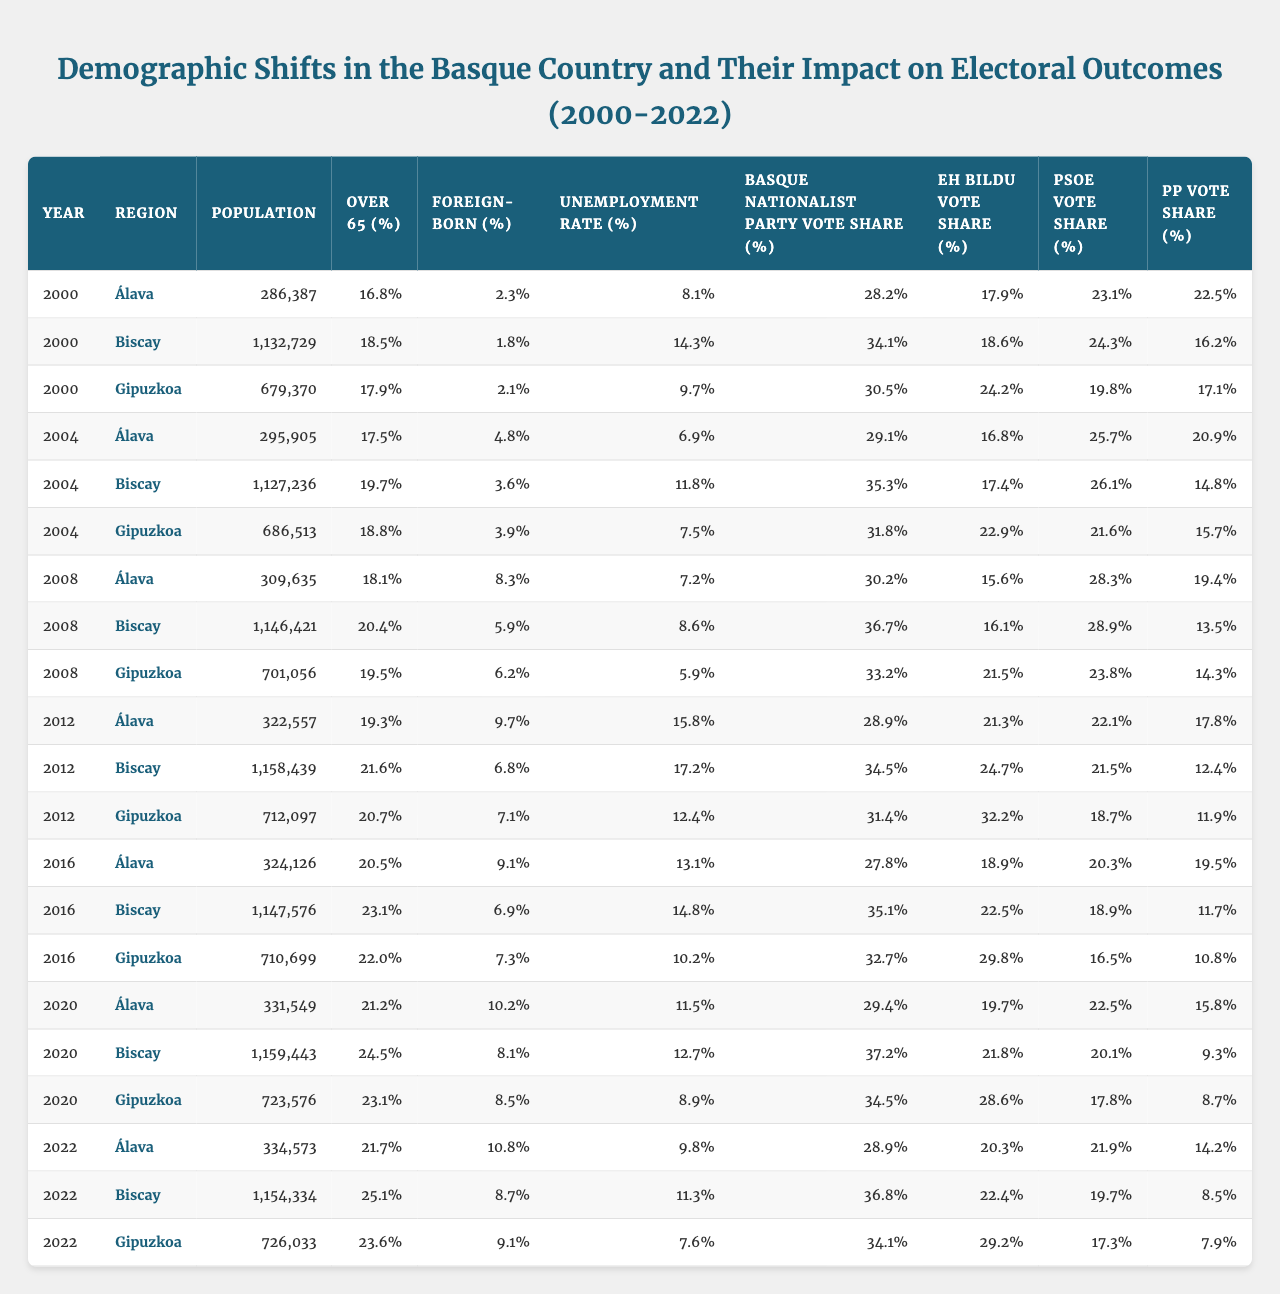What was the unemployment rate in Biscay in 2012? From the table, I look for the row where the year is 2012 and the region is Biscay. The unemployment rate for Biscay in that year is listed as 17.2%.
Answer: 17.2% Which region had the highest foreign-born percentage in 2020? Checking the rows for the year 2020, I compare the foreign-born percentages for Álava (10.2%), Biscay (8.1%), and Gipuzkoa (8.5%). Álava has the highest percentage at 10.2%.
Answer: Álava What is the average percentage of people over 65 in Gipuzkoa across all years? I sum the over 65 percentages for Gipuzkoa from each year: (17.9 + 18.8 + 19.5 + 20.7 + 22.0 + 23.1 + 23.6) = 145.6. There are 7 data points, so the average is 145.6 / 7 ≈ 20.8%.
Answer: 20.8% Did the Basque Nationalist Party’s vote share increase from 2000 to 2022 in Biscay? I compare the Basque Nationalist Party’s vote shares in Biscay for 2000 (34.1%) and 2022 (36.8%). Since 36.8% is greater than 34.1%, it means the party's vote share has increased.
Answer: Yes What was the percentage difference in PSOE vote share between Gipuzkoa in 2020 and 2022? First, I find the PSOE vote shares for Gipuzkoa: in 2020 it is 17.8% and in 2022 it is 17.3%. The difference is 17.8 - 17.3 = 0.5%, indicating a decrease.
Answer: 0.5% Which region had the lowest voter share for the PP in 2020? Checking the table for 2020, I find the PP vote shares: Álava (15.8%), Biscay (9.3%), and Gipuzkoa (8.7%). Gipuzkoa has the lowest vote share at 8.7%.
Answer: Gipuzkoa How did the unemployment rate in Álava change from 2004 to 2022? In 2004, the unemployment rate in Álava is 6.9%. By 2022, it has changed to 9.8%. The increase is calculated as 9.8 - 6.9 = 2.9 percentage points.
Answer: Increased by 2.9 points What was the total population in Biscay across all years provided? I sum the populations for Biscay: (1,132,729 + 1,127,236 + 1,146,421 + 1,158,439 + 1,157,576 + 1,159,443 + 1,154,334) = 8,565,811.
Answer: 8,565,811 Did the percentage of people over 65 decrease in any region from 2000 to 2022? I examine the over 65 percentages for each region from 2000 to 2022: Álava (16.8 to 21.7), Biscay (18.5 to 25.1), Gipuzkoa (17.9 to 23.6). All percentages have increased, confirming no decrease occurred.
Answer: No Which year and region had the highest vote share for EH Bildu? Reviewing the EH Bildu vote shares, I see the highest is 32.2% in Gipuzkoa in 2012.
Answer: Gipuzkoa, 2012 What is the trend for foreign-born percentage in Álava from 2000 to 2022? I observe the foreign-born percentages in Álava: (2.3%, 4.8%, 8.3%, 9.7%, 10.2%, 10.8%). This shows a clear increasing trend over the years.
Answer: Increasing trend 